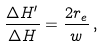<formula> <loc_0><loc_0><loc_500><loc_500>\frac { \Delta H ^ { \prime } } { \Delta H } = \frac { 2 r _ { e } } { w } \, ,</formula> 